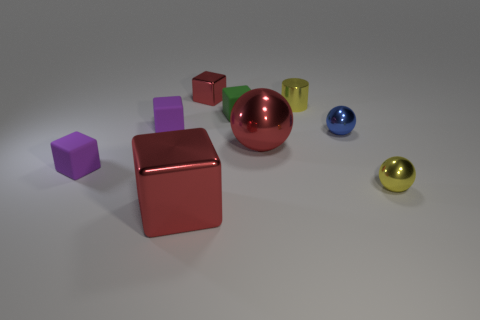Subtract all red cubes. How many cubes are left? 3 Subtract all red spheres. How many spheres are left? 2 Subtract 1 cylinders. How many cylinders are left? 0 Subtract all green cylinders. How many brown spheres are left? 0 Subtract all big shiny things. Subtract all tiny blue spheres. How many objects are left? 6 Add 1 yellow metal cylinders. How many yellow metal cylinders are left? 2 Add 6 cyan balls. How many cyan balls exist? 6 Subtract 0 green balls. How many objects are left? 9 Subtract all cylinders. How many objects are left? 8 Subtract all red blocks. Subtract all red spheres. How many blocks are left? 3 